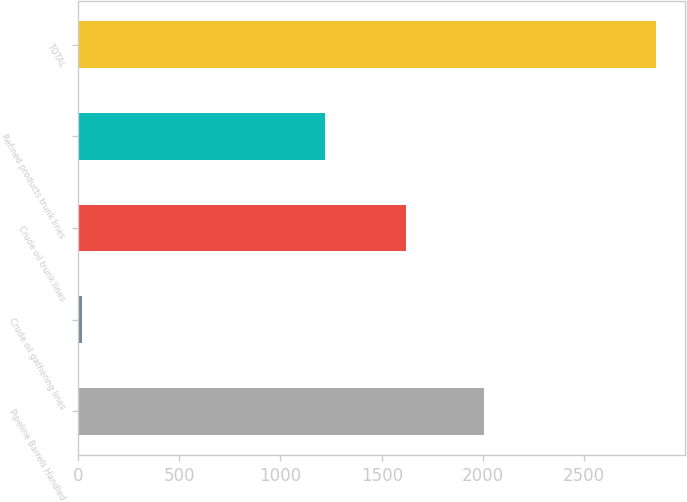Convert chart. <chart><loc_0><loc_0><loc_500><loc_500><bar_chart><fcel>Pipeline Barrels Handled<fcel>Crude oil gathering lines<fcel>Crude oil trunk lines<fcel>Refined products trunk lines<fcel>TOTAL<nl><fcel>2005<fcel>18<fcel>1619<fcel>1219<fcel>2856<nl></chart> 